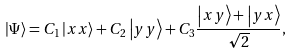Convert formula to latex. <formula><loc_0><loc_0><loc_500><loc_500>\left | \Psi \right \rangle = C _ { 1 } \left | x x \right \rangle + C _ { 2 } \left | y y \right \rangle + C _ { 3 } \frac { \left | x y \right \rangle + \left | y x \right \rangle } { \sqrt { 2 } } ,</formula> 